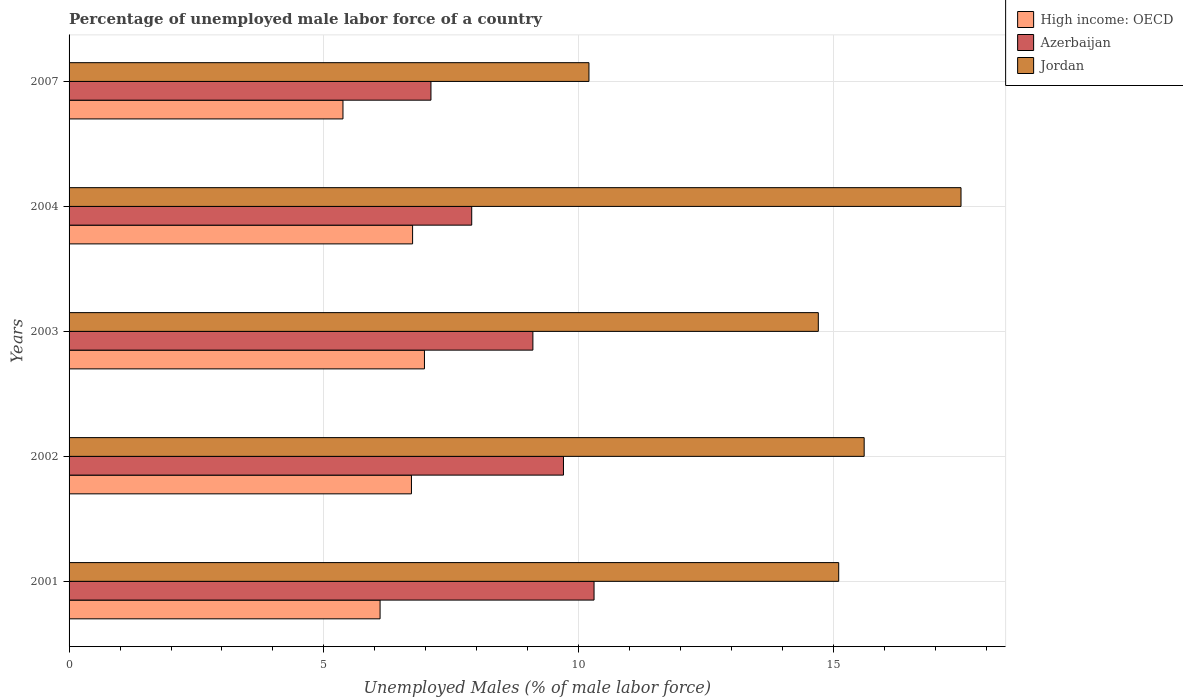How many different coloured bars are there?
Your response must be concise. 3. Are the number of bars per tick equal to the number of legend labels?
Your answer should be compact. Yes. Are the number of bars on each tick of the Y-axis equal?
Provide a short and direct response. Yes. What is the label of the 5th group of bars from the top?
Provide a succinct answer. 2001. In how many cases, is the number of bars for a given year not equal to the number of legend labels?
Your answer should be very brief. 0. What is the percentage of unemployed male labor force in Azerbaijan in 2003?
Your answer should be compact. 9.1. Across all years, what is the maximum percentage of unemployed male labor force in Jordan?
Ensure brevity in your answer.  17.5. Across all years, what is the minimum percentage of unemployed male labor force in Azerbaijan?
Your response must be concise. 7.1. What is the total percentage of unemployed male labor force in Jordan in the graph?
Ensure brevity in your answer.  73.1. What is the difference between the percentage of unemployed male labor force in Azerbaijan in 2004 and the percentage of unemployed male labor force in High income: OECD in 2001?
Make the answer very short. 1.8. What is the average percentage of unemployed male labor force in Jordan per year?
Provide a short and direct response. 14.62. In the year 2007, what is the difference between the percentage of unemployed male labor force in Azerbaijan and percentage of unemployed male labor force in Jordan?
Ensure brevity in your answer.  -3.1. What is the ratio of the percentage of unemployed male labor force in Jordan in 2004 to that in 2007?
Your answer should be very brief. 1.72. Is the difference between the percentage of unemployed male labor force in Azerbaijan in 2001 and 2002 greater than the difference between the percentage of unemployed male labor force in Jordan in 2001 and 2002?
Keep it short and to the point. Yes. What is the difference between the highest and the second highest percentage of unemployed male labor force in Jordan?
Give a very brief answer. 1.9. What is the difference between the highest and the lowest percentage of unemployed male labor force in Azerbaijan?
Offer a terse response. 3.2. Is the sum of the percentage of unemployed male labor force in High income: OECD in 2004 and 2007 greater than the maximum percentage of unemployed male labor force in Azerbaijan across all years?
Your answer should be very brief. Yes. What does the 1st bar from the top in 2007 represents?
Make the answer very short. Jordan. What does the 2nd bar from the bottom in 2002 represents?
Your answer should be compact. Azerbaijan. Is it the case that in every year, the sum of the percentage of unemployed male labor force in Jordan and percentage of unemployed male labor force in Azerbaijan is greater than the percentage of unemployed male labor force in High income: OECD?
Offer a very short reply. Yes. What is the title of the graph?
Your answer should be compact. Percentage of unemployed male labor force of a country. What is the label or title of the X-axis?
Give a very brief answer. Unemployed Males (% of male labor force). What is the Unemployed Males (% of male labor force) of High income: OECD in 2001?
Make the answer very short. 6.1. What is the Unemployed Males (% of male labor force) in Azerbaijan in 2001?
Offer a terse response. 10.3. What is the Unemployed Males (% of male labor force) in Jordan in 2001?
Keep it short and to the point. 15.1. What is the Unemployed Males (% of male labor force) in High income: OECD in 2002?
Keep it short and to the point. 6.72. What is the Unemployed Males (% of male labor force) of Azerbaijan in 2002?
Ensure brevity in your answer.  9.7. What is the Unemployed Males (% of male labor force) in Jordan in 2002?
Offer a very short reply. 15.6. What is the Unemployed Males (% of male labor force) in High income: OECD in 2003?
Keep it short and to the point. 6.97. What is the Unemployed Males (% of male labor force) of Azerbaijan in 2003?
Provide a succinct answer. 9.1. What is the Unemployed Males (% of male labor force) in Jordan in 2003?
Your answer should be very brief. 14.7. What is the Unemployed Males (% of male labor force) in High income: OECD in 2004?
Provide a succinct answer. 6.74. What is the Unemployed Males (% of male labor force) in Azerbaijan in 2004?
Your answer should be compact. 7.9. What is the Unemployed Males (% of male labor force) of High income: OECD in 2007?
Offer a terse response. 5.37. What is the Unemployed Males (% of male labor force) in Azerbaijan in 2007?
Your answer should be very brief. 7.1. What is the Unemployed Males (% of male labor force) in Jordan in 2007?
Your answer should be very brief. 10.2. Across all years, what is the maximum Unemployed Males (% of male labor force) of High income: OECD?
Offer a very short reply. 6.97. Across all years, what is the maximum Unemployed Males (% of male labor force) of Azerbaijan?
Give a very brief answer. 10.3. Across all years, what is the maximum Unemployed Males (% of male labor force) of Jordan?
Offer a very short reply. 17.5. Across all years, what is the minimum Unemployed Males (% of male labor force) in High income: OECD?
Make the answer very short. 5.37. Across all years, what is the minimum Unemployed Males (% of male labor force) of Azerbaijan?
Make the answer very short. 7.1. Across all years, what is the minimum Unemployed Males (% of male labor force) of Jordan?
Provide a short and direct response. 10.2. What is the total Unemployed Males (% of male labor force) of High income: OECD in the graph?
Offer a terse response. 31.91. What is the total Unemployed Males (% of male labor force) in Azerbaijan in the graph?
Your answer should be compact. 44.1. What is the total Unemployed Males (% of male labor force) in Jordan in the graph?
Give a very brief answer. 73.1. What is the difference between the Unemployed Males (% of male labor force) of High income: OECD in 2001 and that in 2002?
Offer a very short reply. -0.62. What is the difference between the Unemployed Males (% of male labor force) in High income: OECD in 2001 and that in 2003?
Provide a short and direct response. -0.87. What is the difference between the Unemployed Males (% of male labor force) of High income: OECD in 2001 and that in 2004?
Provide a short and direct response. -0.64. What is the difference between the Unemployed Males (% of male labor force) in High income: OECD in 2001 and that in 2007?
Offer a terse response. 0.73. What is the difference between the Unemployed Males (% of male labor force) in Azerbaijan in 2001 and that in 2007?
Your response must be concise. 3.2. What is the difference between the Unemployed Males (% of male labor force) in High income: OECD in 2002 and that in 2003?
Provide a succinct answer. -0.26. What is the difference between the Unemployed Males (% of male labor force) in Jordan in 2002 and that in 2003?
Give a very brief answer. 0.9. What is the difference between the Unemployed Males (% of male labor force) in High income: OECD in 2002 and that in 2004?
Offer a very short reply. -0.02. What is the difference between the Unemployed Males (% of male labor force) of High income: OECD in 2002 and that in 2007?
Make the answer very short. 1.34. What is the difference between the Unemployed Males (% of male labor force) in Azerbaijan in 2002 and that in 2007?
Provide a short and direct response. 2.6. What is the difference between the Unemployed Males (% of male labor force) in Jordan in 2002 and that in 2007?
Your answer should be compact. 5.4. What is the difference between the Unemployed Males (% of male labor force) of High income: OECD in 2003 and that in 2004?
Ensure brevity in your answer.  0.23. What is the difference between the Unemployed Males (% of male labor force) in Azerbaijan in 2003 and that in 2004?
Your answer should be very brief. 1.2. What is the difference between the Unemployed Males (% of male labor force) of Jordan in 2003 and that in 2004?
Give a very brief answer. -2.8. What is the difference between the Unemployed Males (% of male labor force) in High income: OECD in 2003 and that in 2007?
Ensure brevity in your answer.  1.6. What is the difference between the Unemployed Males (% of male labor force) of High income: OECD in 2004 and that in 2007?
Make the answer very short. 1.37. What is the difference between the Unemployed Males (% of male labor force) of Azerbaijan in 2004 and that in 2007?
Keep it short and to the point. 0.8. What is the difference between the Unemployed Males (% of male labor force) in High income: OECD in 2001 and the Unemployed Males (% of male labor force) in Azerbaijan in 2002?
Make the answer very short. -3.6. What is the difference between the Unemployed Males (% of male labor force) of High income: OECD in 2001 and the Unemployed Males (% of male labor force) of Jordan in 2002?
Provide a succinct answer. -9.5. What is the difference between the Unemployed Males (% of male labor force) in Azerbaijan in 2001 and the Unemployed Males (% of male labor force) in Jordan in 2002?
Ensure brevity in your answer.  -5.3. What is the difference between the Unemployed Males (% of male labor force) of High income: OECD in 2001 and the Unemployed Males (% of male labor force) of Azerbaijan in 2003?
Your response must be concise. -3. What is the difference between the Unemployed Males (% of male labor force) in High income: OECD in 2001 and the Unemployed Males (% of male labor force) in Jordan in 2003?
Your answer should be compact. -8.6. What is the difference between the Unemployed Males (% of male labor force) of Azerbaijan in 2001 and the Unemployed Males (% of male labor force) of Jordan in 2003?
Give a very brief answer. -4.4. What is the difference between the Unemployed Males (% of male labor force) in High income: OECD in 2001 and the Unemployed Males (% of male labor force) in Azerbaijan in 2004?
Ensure brevity in your answer.  -1.8. What is the difference between the Unemployed Males (% of male labor force) in High income: OECD in 2001 and the Unemployed Males (% of male labor force) in Jordan in 2004?
Make the answer very short. -11.4. What is the difference between the Unemployed Males (% of male labor force) of High income: OECD in 2001 and the Unemployed Males (% of male labor force) of Azerbaijan in 2007?
Your answer should be very brief. -1. What is the difference between the Unemployed Males (% of male labor force) in High income: OECD in 2001 and the Unemployed Males (% of male labor force) in Jordan in 2007?
Keep it short and to the point. -4.1. What is the difference between the Unemployed Males (% of male labor force) of Azerbaijan in 2001 and the Unemployed Males (% of male labor force) of Jordan in 2007?
Your response must be concise. 0.1. What is the difference between the Unemployed Males (% of male labor force) of High income: OECD in 2002 and the Unemployed Males (% of male labor force) of Azerbaijan in 2003?
Make the answer very short. -2.38. What is the difference between the Unemployed Males (% of male labor force) of High income: OECD in 2002 and the Unemployed Males (% of male labor force) of Jordan in 2003?
Offer a very short reply. -7.98. What is the difference between the Unemployed Males (% of male labor force) in High income: OECD in 2002 and the Unemployed Males (% of male labor force) in Azerbaijan in 2004?
Your answer should be compact. -1.18. What is the difference between the Unemployed Males (% of male labor force) in High income: OECD in 2002 and the Unemployed Males (% of male labor force) in Jordan in 2004?
Offer a very short reply. -10.78. What is the difference between the Unemployed Males (% of male labor force) of High income: OECD in 2002 and the Unemployed Males (% of male labor force) of Azerbaijan in 2007?
Your response must be concise. -0.38. What is the difference between the Unemployed Males (% of male labor force) of High income: OECD in 2002 and the Unemployed Males (% of male labor force) of Jordan in 2007?
Your response must be concise. -3.48. What is the difference between the Unemployed Males (% of male labor force) in Azerbaijan in 2002 and the Unemployed Males (% of male labor force) in Jordan in 2007?
Make the answer very short. -0.5. What is the difference between the Unemployed Males (% of male labor force) of High income: OECD in 2003 and the Unemployed Males (% of male labor force) of Azerbaijan in 2004?
Keep it short and to the point. -0.93. What is the difference between the Unemployed Males (% of male labor force) of High income: OECD in 2003 and the Unemployed Males (% of male labor force) of Jordan in 2004?
Make the answer very short. -10.53. What is the difference between the Unemployed Males (% of male labor force) of Azerbaijan in 2003 and the Unemployed Males (% of male labor force) of Jordan in 2004?
Ensure brevity in your answer.  -8.4. What is the difference between the Unemployed Males (% of male labor force) of High income: OECD in 2003 and the Unemployed Males (% of male labor force) of Azerbaijan in 2007?
Your answer should be very brief. -0.13. What is the difference between the Unemployed Males (% of male labor force) in High income: OECD in 2003 and the Unemployed Males (% of male labor force) in Jordan in 2007?
Provide a succinct answer. -3.23. What is the difference between the Unemployed Males (% of male labor force) of Azerbaijan in 2003 and the Unemployed Males (% of male labor force) of Jordan in 2007?
Your answer should be compact. -1.1. What is the difference between the Unemployed Males (% of male labor force) in High income: OECD in 2004 and the Unemployed Males (% of male labor force) in Azerbaijan in 2007?
Provide a succinct answer. -0.36. What is the difference between the Unemployed Males (% of male labor force) of High income: OECD in 2004 and the Unemployed Males (% of male labor force) of Jordan in 2007?
Offer a very short reply. -3.46. What is the difference between the Unemployed Males (% of male labor force) of Azerbaijan in 2004 and the Unemployed Males (% of male labor force) of Jordan in 2007?
Provide a succinct answer. -2.3. What is the average Unemployed Males (% of male labor force) of High income: OECD per year?
Your response must be concise. 6.38. What is the average Unemployed Males (% of male labor force) in Azerbaijan per year?
Offer a very short reply. 8.82. What is the average Unemployed Males (% of male labor force) of Jordan per year?
Your response must be concise. 14.62. In the year 2001, what is the difference between the Unemployed Males (% of male labor force) in High income: OECD and Unemployed Males (% of male labor force) in Azerbaijan?
Provide a succinct answer. -4.2. In the year 2001, what is the difference between the Unemployed Males (% of male labor force) of High income: OECD and Unemployed Males (% of male labor force) of Jordan?
Offer a terse response. -9. In the year 2002, what is the difference between the Unemployed Males (% of male labor force) of High income: OECD and Unemployed Males (% of male labor force) of Azerbaijan?
Give a very brief answer. -2.98. In the year 2002, what is the difference between the Unemployed Males (% of male labor force) in High income: OECD and Unemployed Males (% of male labor force) in Jordan?
Give a very brief answer. -8.88. In the year 2003, what is the difference between the Unemployed Males (% of male labor force) of High income: OECD and Unemployed Males (% of male labor force) of Azerbaijan?
Your response must be concise. -2.13. In the year 2003, what is the difference between the Unemployed Males (% of male labor force) of High income: OECD and Unemployed Males (% of male labor force) of Jordan?
Keep it short and to the point. -7.73. In the year 2004, what is the difference between the Unemployed Males (% of male labor force) of High income: OECD and Unemployed Males (% of male labor force) of Azerbaijan?
Provide a succinct answer. -1.16. In the year 2004, what is the difference between the Unemployed Males (% of male labor force) in High income: OECD and Unemployed Males (% of male labor force) in Jordan?
Offer a very short reply. -10.76. In the year 2004, what is the difference between the Unemployed Males (% of male labor force) in Azerbaijan and Unemployed Males (% of male labor force) in Jordan?
Provide a succinct answer. -9.6. In the year 2007, what is the difference between the Unemployed Males (% of male labor force) in High income: OECD and Unemployed Males (% of male labor force) in Azerbaijan?
Give a very brief answer. -1.73. In the year 2007, what is the difference between the Unemployed Males (% of male labor force) in High income: OECD and Unemployed Males (% of male labor force) in Jordan?
Your response must be concise. -4.83. What is the ratio of the Unemployed Males (% of male labor force) in High income: OECD in 2001 to that in 2002?
Your response must be concise. 0.91. What is the ratio of the Unemployed Males (% of male labor force) in Azerbaijan in 2001 to that in 2002?
Make the answer very short. 1.06. What is the ratio of the Unemployed Males (% of male labor force) in Jordan in 2001 to that in 2002?
Your answer should be compact. 0.97. What is the ratio of the Unemployed Males (% of male labor force) of High income: OECD in 2001 to that in 2003?
Your response must be concise. 0.88. What is the ratio of the Unemployed Males (% of male labor force) of Azerbaijan in 2001 to that in 2003?
Provide a short and direct response. 1.13. What is the ratio of the Unemployed Males (% of male labor force) of Jordan in 2001 to that in 2003?
Make the answer very short. 1.03. What is the ratio of the Unemployed Males (% of male labor force) in High income: OECD in 2001 to that in 2004?
Provide a succinct answer. 0.91. What is the ratio of the Unemployed Males (% of male labor force) of Azerbaijan in 2001 to that in 2004?
Make the answer very short. 1.3. What is the ratio of the Unemployed Males (% of male labor force) of Jordan in 2001 to that in 2004?
Provide a succinct answer. 0.86. What is the ratio of the Unemployed Males (% of male labor force) in High income: OECD in 2001 to that in 2007?
Provide a succinct answer. 1.14. What is the ratio of the Unemployed Males (% of male labor force) in Azerbaijan in 2001 to that in 2007?
Your answer should be compact. 1.45. What is the ratio of the Unemployed Males (% of male labor force) in Jordan in 2001 to that in 2007?
Provide a succinct answer. 1.48. What is the ratio of the Unemployed Males (% of male labor force) in High income: OECD in 2002 to that in 2003?
Offer a very short reply. 0.96. What is the ratio of the Unemployed Males (% of male labor force) in Azerbaijan in 2002 to that in 2003?
Your answer should be compact. 1.07. What is the ratio of the Unemployed Males (% of male labor force) of Jordan in 2002 to that in 2003?
Offer a very short reply. 1.06. What is the ratio of the Unemployed Males (% of male labor force) of High income: OECD in 2002 to that in 2004?
Offer a terse response. 1. What is the ratio of the Unemployed Males (% of male labor force) of Azerbaijan in 2002 to that in 2004?
Provide a short and direct response. 1.23. What is the ratio of the Unemployed Males (% of male labor force) in Jordan in 2002 to that in 2004?
Ensure brevity in your answer.  0.89. What is the ratio of the Unemployed Males (% of male labor force) of High income: OECD in 2002 to that in 2007?
Your answer should be very brief. 1.25. What is the ratio of the Unemployed Males (% of male labor force) in Azerbaijan in 2002 to that in 2007?
Keep it short and to the point. 1.37. What is the ratio of the Unemployed Males (% of male labor force) of Jordan in 2002 to that in 2007?
Offer a very short reply. 1.53. What is the ratio of the Unemployed Males (% of male labor force) in High income: OECD in 2003 to that in 2004?
Offer a very short reply. 1.03. What is the ratio of the Unemployed Males (% of male labor force) in Azerbaijan in 2003 to that in 2004?
Make the answer very short. 1.15. What is the ratio of the Unemployed Males (% of male labor force) of Jordan in 2003 to that in 2004?
Give a very brief answer. 0.84. What is the ratio of the Unemployed Males (% of male labor force) of High income: OECD in 2003 to that in 2007?
Your answer should be compact. 1.3. What is the ratio of the Unemployed Males (% of male labor force) of Azerbaijan in 2003 to that in 2007?
Give a very brief answer. 1.28. What is the ratio of the Unemployed Males (% of male labor force) in Jordan in 2003 to that in 2007?
Offer a very short reply. 1.44. What is the ratio of the Unemployed Males (% of male labor force) in High income: OECD in 2004 to that in 2007?
Provide a succinct answer. 1.25. What is the ratio of the Unemployed Males (% of male labor force) of Azerbaijan in 2004 to that in 2007?
Offer a terse response. 1.11. What is the ratio of the Unemployed Males (% of male labor force) in Jordan in 2004 to that in 2007?
Keep it short and to the point. 1.72. What is the difference between the highest and the second highest Unemployed Males (% of male labor force) of High income: OECD?
Provide a short and direct response. 0.23. What is the difference between the highest and the lowest Unemployed Males (% of male labor force) in High income: OECD?
Make the answer very short. 1.6. What is the difference between the highest and the lowest Unemployed Males (% of male labor force) of Azerbaijan?
Your answer should be compact. 3.2. 